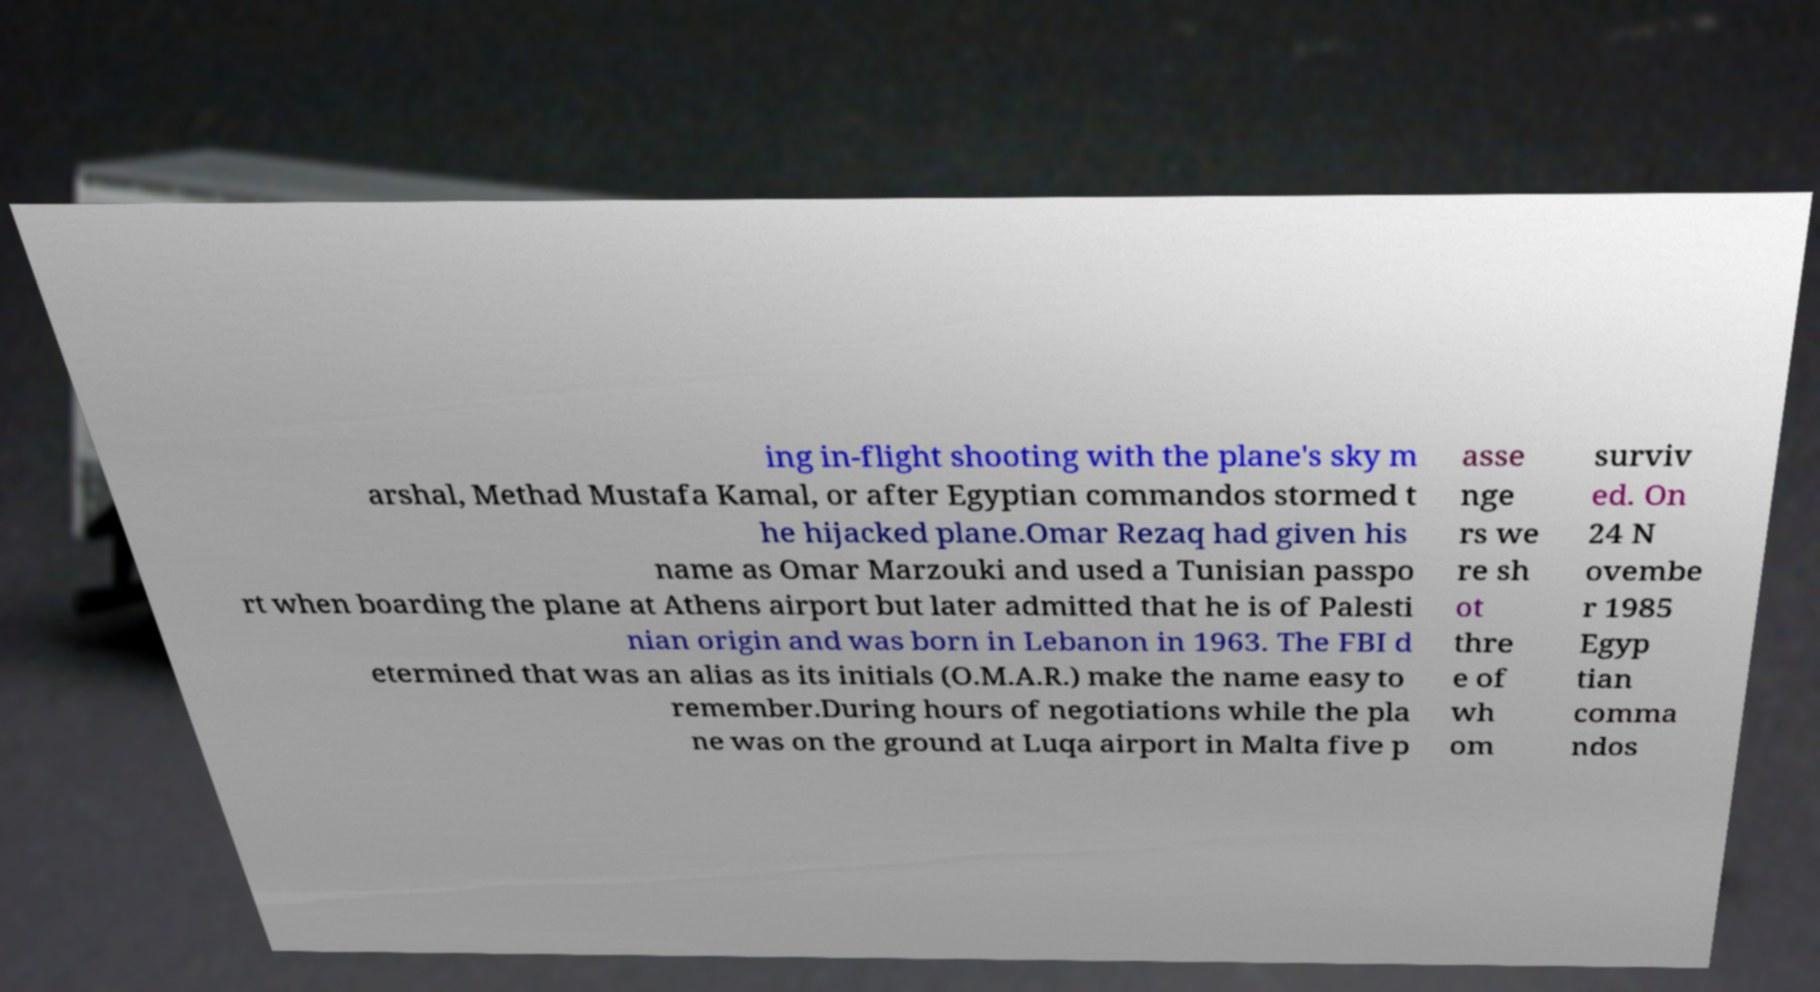I need the written content from this picture converted into text. Can you do that? ing in-flight shooting with the plane's sky m arshal, Methad Mustafa Kamal, or after Egyptian commandos stormed t he hijacked plane.Omar Rezaq had given his name as Omar Marzouki and used a Tunisian passpo rt when boarding the plane at Athens airport but later admitted that he is of Palesti nian origin and was born in Lebanon in 1963. The FBI d etermined that was an alias as its initials (O.M.A.R.) make the name easy to remember.During hours of negotiations while the pla ne was on the ground at Luqa airport in Malta five p asse nge rs we re sh ot thre e of wh om surviv ed. On 24 N ovembe r 1985 Egyp tian comma ndos 